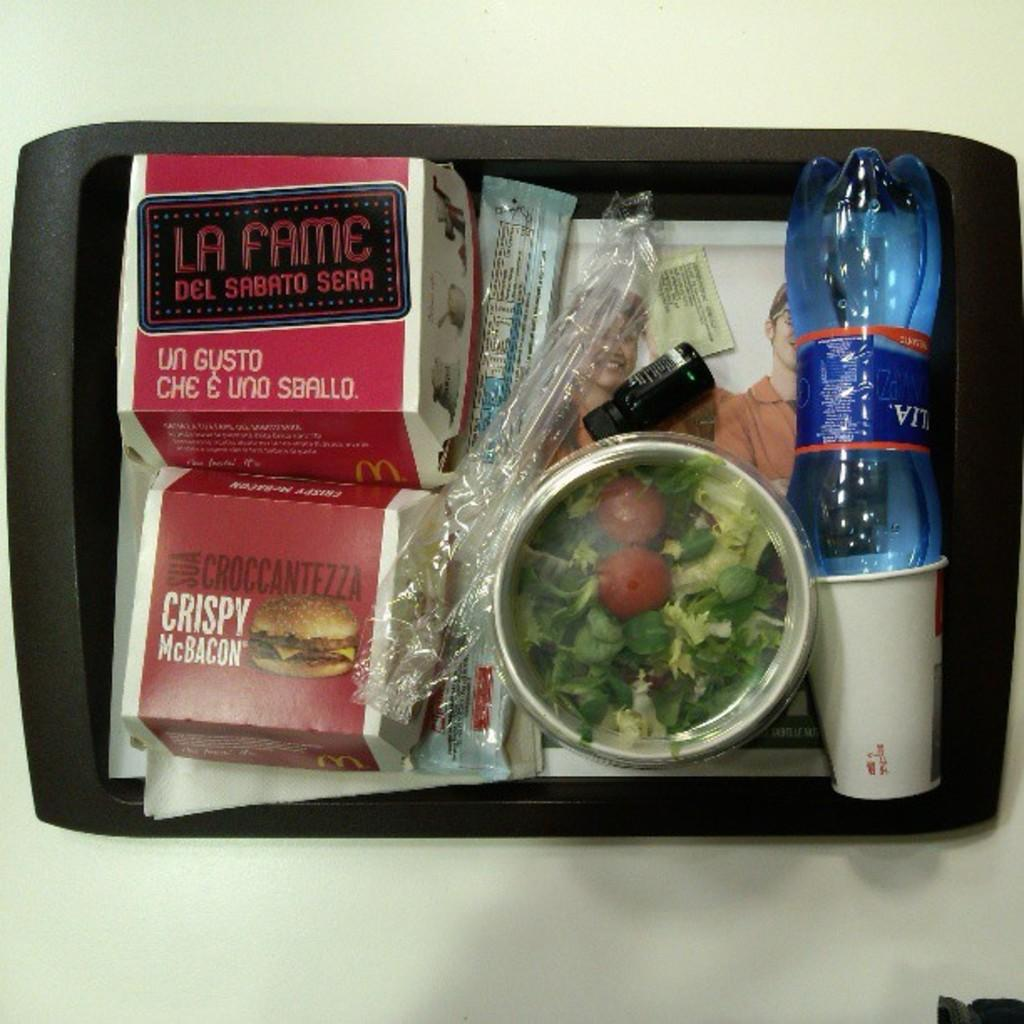<image>
Create a compact narrative representing the image presented. a lunch tray with food including salad, bottled water, LA FAME DEL SABATO SERA AND CRISPY McBacon. 